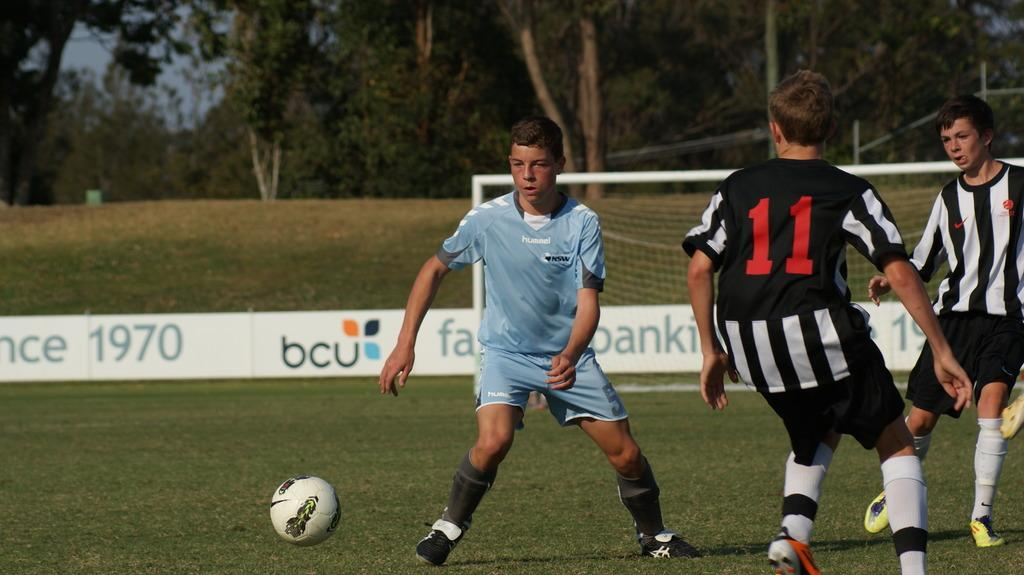What activity are the people in the image engaged in? The people in the image are playing football. What structure is present in the image related to the game? There is a goal court in the image. What type of surface is the game being played on? There is grass visible in the image. What can be seen in the background of the image? There are trees at the back of the image. What word is being shouted by the people playing football in the image? There is no specific word being shouted by the people playing football in the image; they are likely communicating in a variety of ways related to the game. 